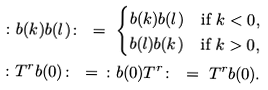Convert formula to latex. <formula><loc_0><loc_0><loc_500><loc_500>& \colon b ( k ) b ( l ) \colon \ = \ \begin{cases} b ( k ) b ( l ) & \text {if $k<0$} , \\ b ( l ) b ( k ) & \text {if $k>0$} , \end{cases} \\ & \colon T ^ { r } b ( 0 ) \colon \ = \ \colon b ( 0 ) T ^ { r } \colon \ = \ T ^ { r } b ( 0 ) .</formula> 